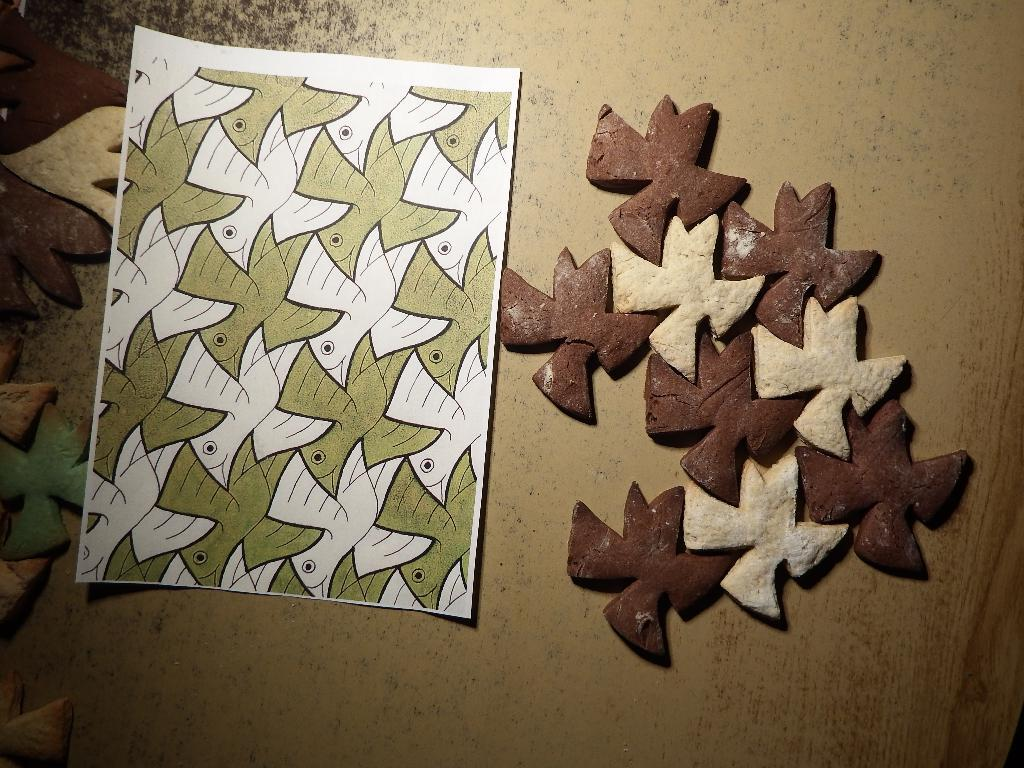What is the main object in the image? There is a paper in the image. What else can be seen in the image besides the paper? There are objects on a platform in the image. What type of flower is growing on the paper in the image? There is no flower present on the paper in the image. 